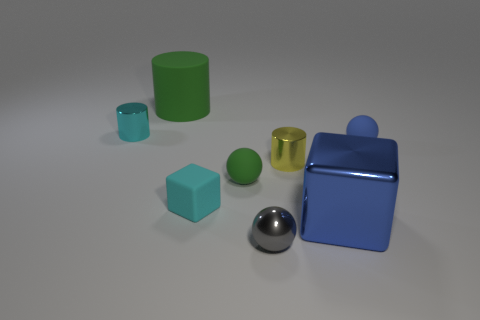There is a green matte cylinder right of the shiny object behind the matte sphere that is to the right of the gray metal object; how big is it?
Offer a terse response. Large. What shape is the small metallic object that is behind the tiny matte cube and right of the green rubber cylinder?
Give a very brief answer. Cylinder. Is the number of green rubber cylinders that are to the right of the large matte object the same as the number of cyan rubber cubes behind the tiny blue matte object?
Offer a terse response. Yes. Are there any blue things that have the same material as the tiny blue sphere?
Keep it short and to the point. No. Do the cube that is to the left of the blue block and the small gray thing have the same material?
Ensure brevity in your answer.  No. There is a cylinder that is to the right of the small cyan shiny cylinder and to the left of the cyan matte object; how big is it?
Give a very brief answer. Large. What color is the big cylinder?
Offer a very short reply. Green. How many small cyan blocks are there?
Provide a short and direct response. 1. How many other tiny shiny balls have the same color as the metallic ball?
Keep it short and to the point. 0. There is a rubber object on the right side of the big blue metal thing; does it have the same shape as the tiny shiny object in front of the small yellow metallic object?
Your answer should be compact. Yes. 